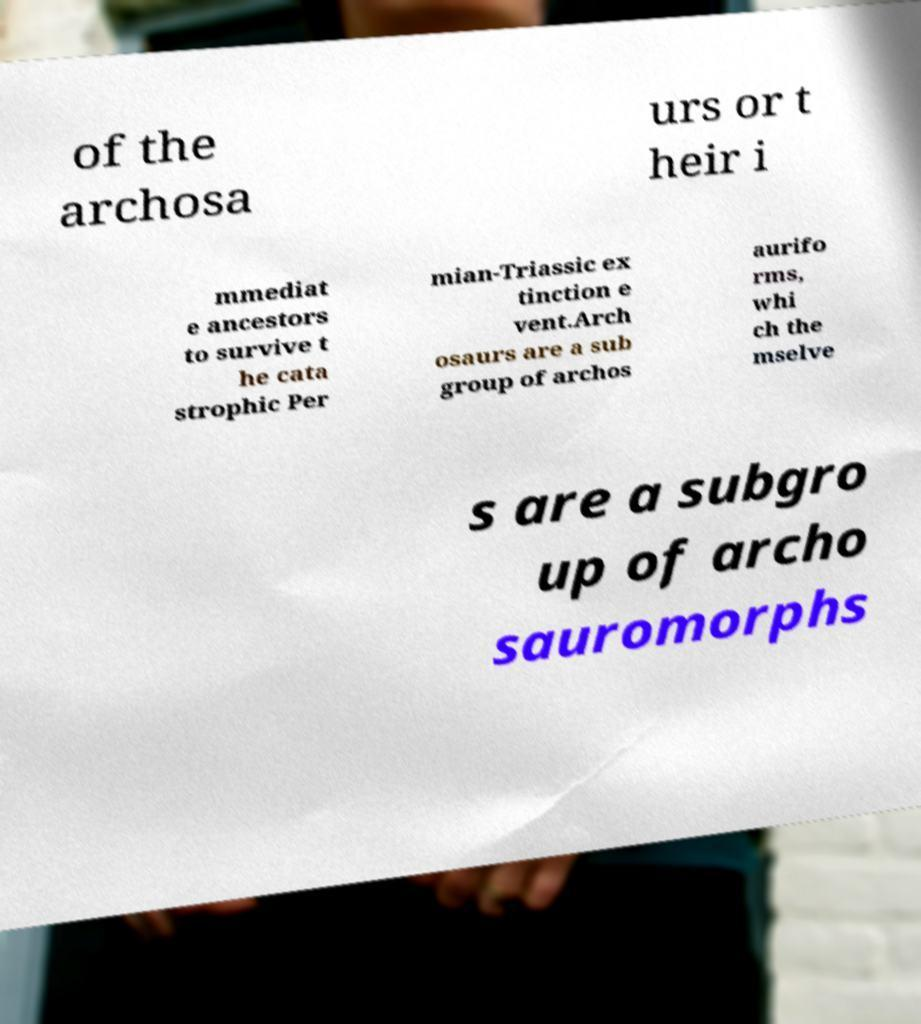Can you read and provide the text displayed in the image?This photo seems to have some interesting text. Can you extract and type it out for me? of the archosa urs or t heir i mmediat e ancestors to survive t he cata strophic Per mian-Triassic ex tinction e vent.Arch osaurs are a sub group of archos aurifo rms, whi ch the mselve s are a subgro up of archo sauromorphs 